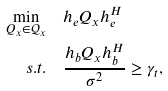Convert formula to latex. <formula><loc_0><loc_0><loc_500><loc_500>\min _ { Q _ { x } \in \mathcal { Q } _ { x } } & \quad h _ { e } Q _ { x } h _ { e } ^ { H } \\ s . t . & \quad \frac { h _ { b } Q _ { x } h _ { b } ^ { H } } { \sigma ^ { 2 } } \geq \gamma _ { t } ,</formula> 